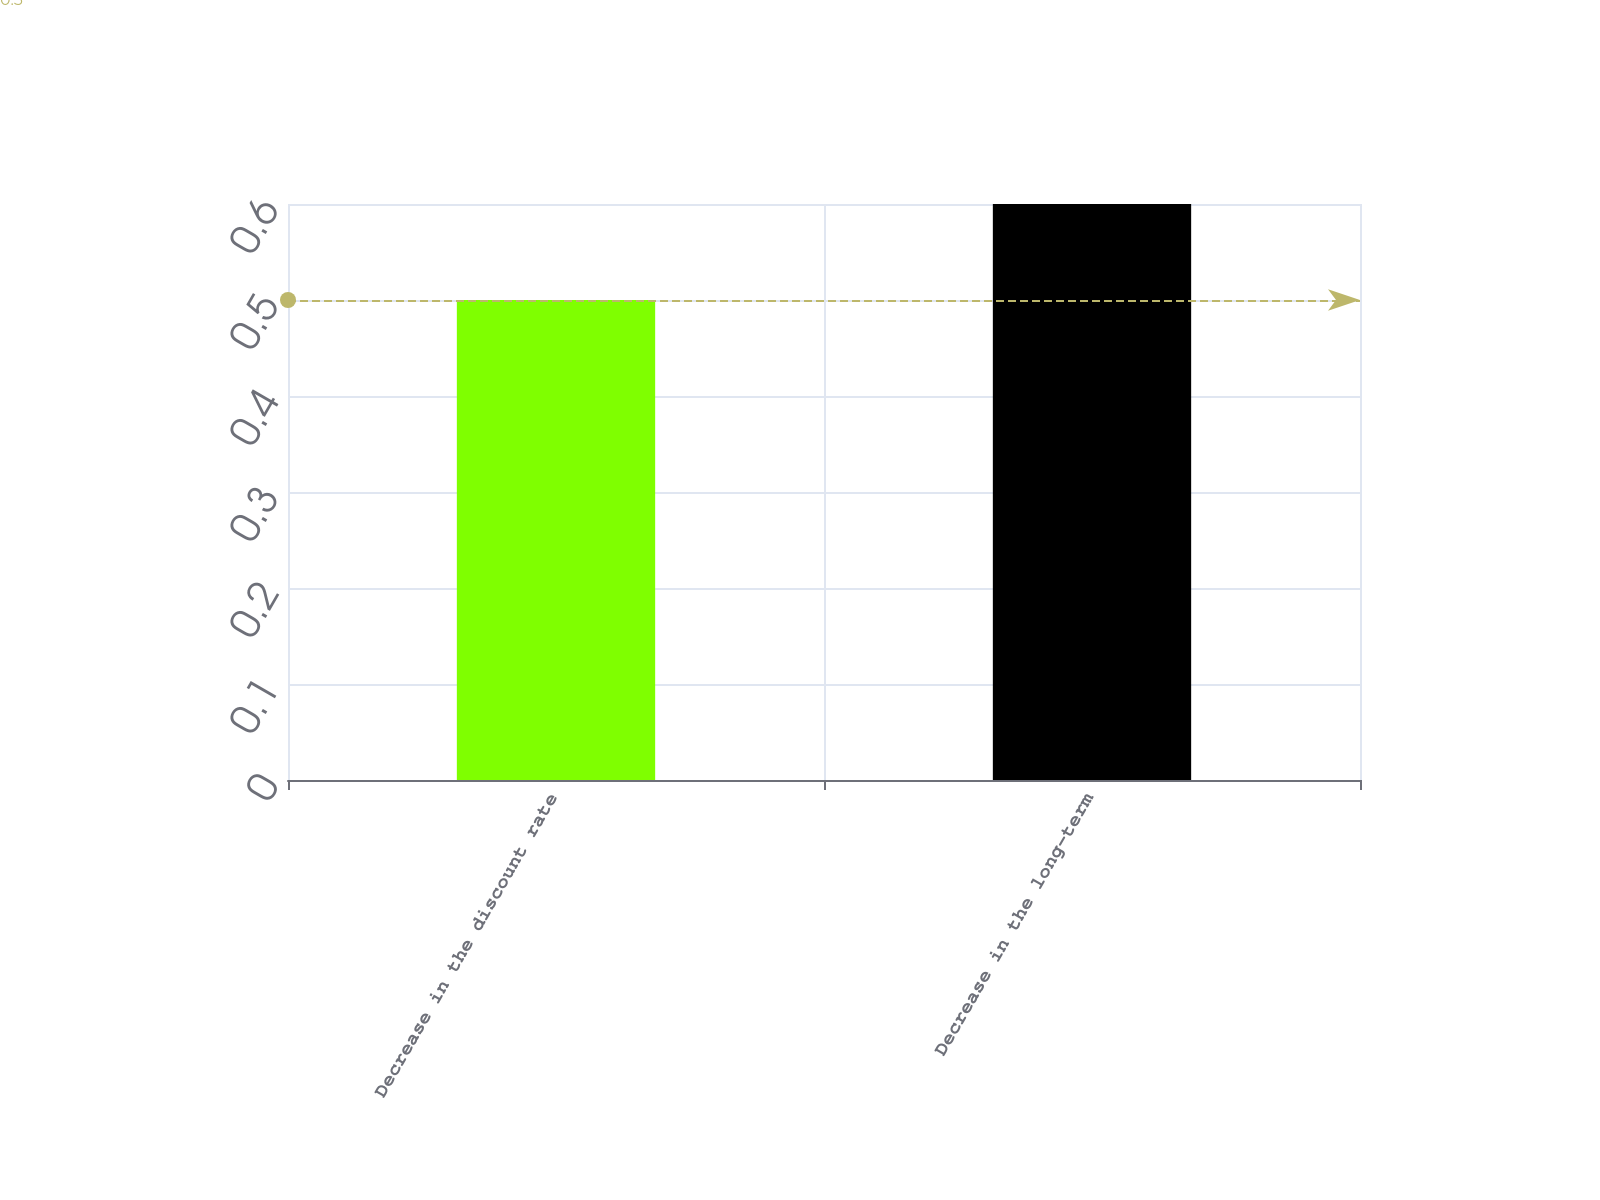<chart> <loc_0><loc_0><loc_500><loc_500><bar_chart><fcel>Decrease in the discount rate<fcel>Decrease in the long-term<nl><fcel>0.5<fcel>0.6<nl></chart> 